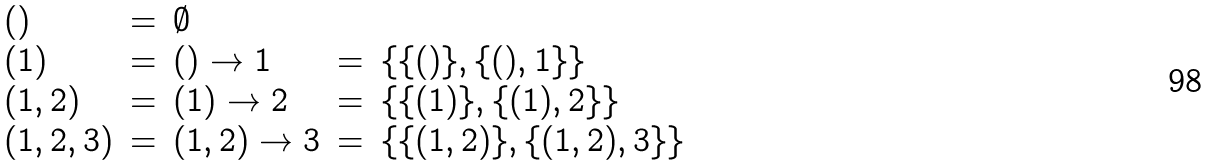Convert formula to latex. <formula><loc_0><loc_0><loc_500><loc_500>\begin{array} { l c l c l } { ( ) } & { = } & { \emptyset } \\ { ( 1 ) } & { = } & { ( ) \rightarrow 1 } & { = } & { \{ \{ ( ) \} , \{ ( ) , 1 \} \} } \\ { ( 1 , 2 ) } & { = } & { ( 1 ) \rightarrow 2 } & { = } & { \{ \{ ( 1 ) \} , \{ ( 1 ) , 2 \} \} } \\ { ( 1 , 2 , 3 ) } & { = } & { ( 1 , 2 ) \rightarrow 3 } & { = } & { \{ \{ ( 1 , 2 ) \} , \{ ( 1 , 2 ) , 3 \} \} } \end{array}</formula> 